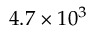<formula> <loc_0><loc_0><loc_500><loc_500>4 . 7 \times 1 0 ^ { 3 }</formula> 